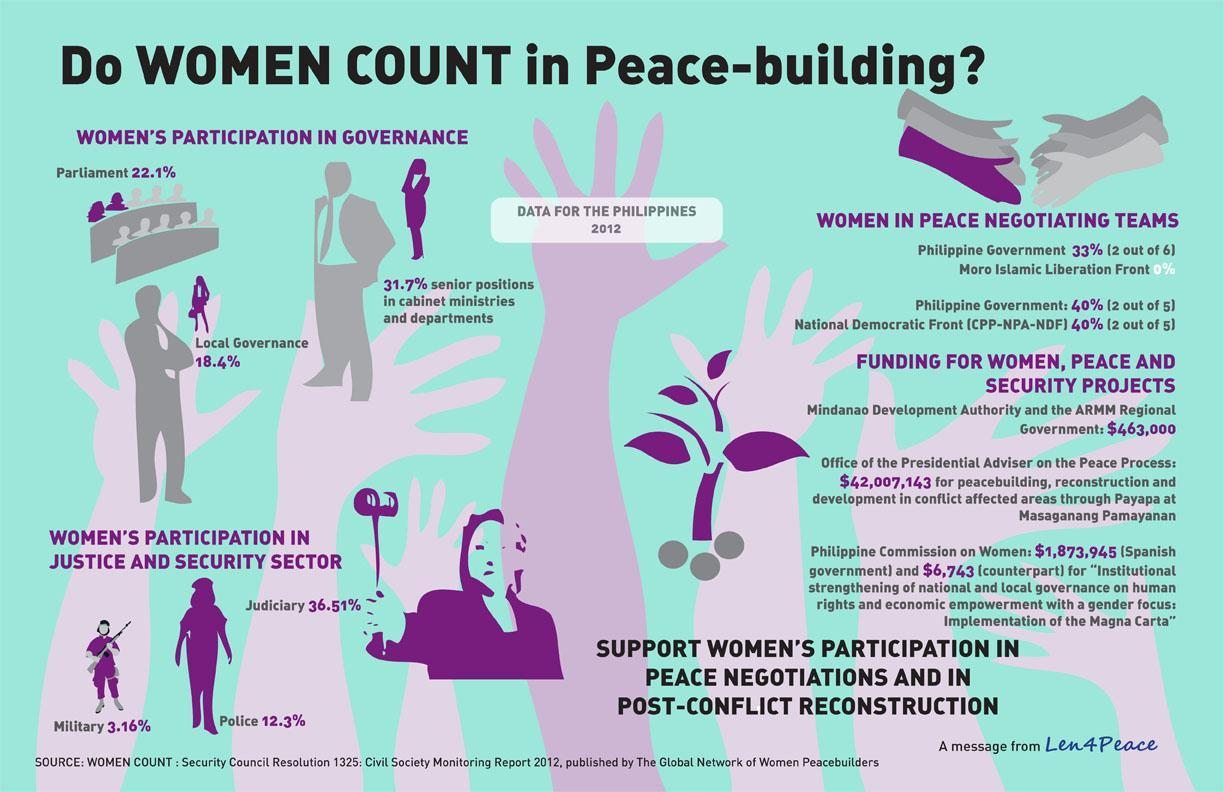What percentage of women represented in Philippines police services according to the Civil Society Monitoring Report 2012?
Answer the question with a short phrase. 12.3% What percentage of women represented in the parliament of Philippines as per the Civil Society Monitoring Report 2012? 22.1% What is the percentage of women in Philippines military services according to the Civil Society Monitoring Report 2012? 3.16% What percentage of women held senior positions in cabinet ministries & departments of Philippines as per the Civil Society Monitoring Report 2012? 31.7% 